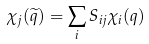Convert formula to latex. <formula><loc_0><loc_0><loc_500><loc_500>\chi _ { j } ( \widetilde { q } ) = \sum _ { i } S _ { i j } \chi _ { i } ( q )</formula> 